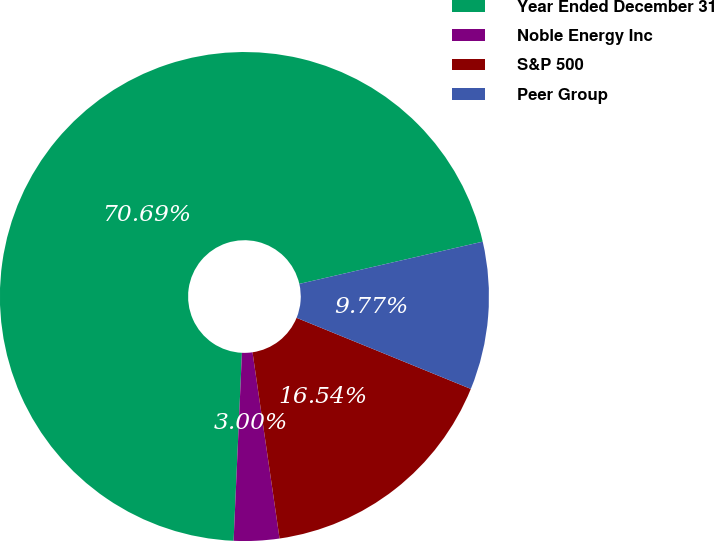Convert chart. <chart><loc_0><loc_0><loc_500><loc_500><pie_chart><fcel>Year Ended December 31<fcel>Noble Energy Inc<fcel>S&P 500<fcel>Peer Group<nl><fcel>70.7%<fcel>3.0%<fcel>16.54%<fcel>9.77%<nl></chart> 